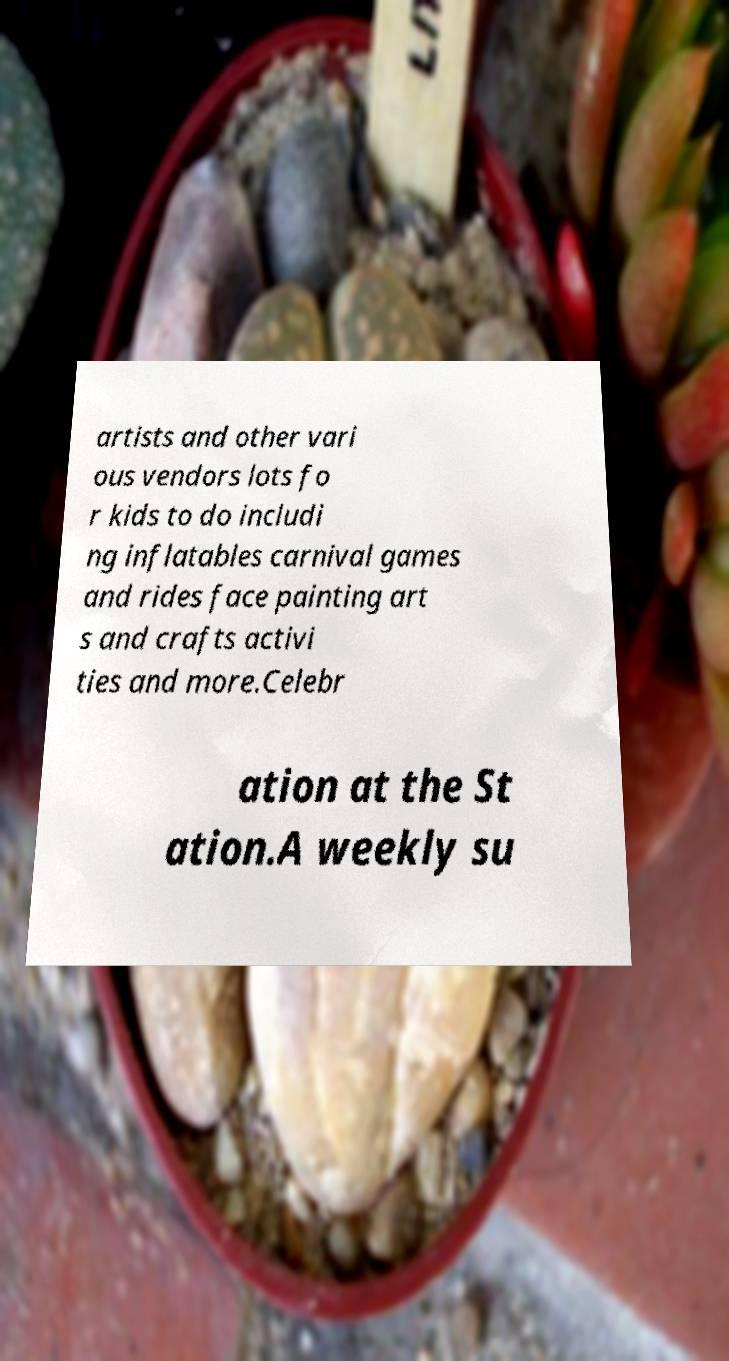Could you assist in decoding the text presented in this image and type it out clearly? artists and other vari ous vendors lots fo r kids to do includi ng inflatables carnival games and rides face painting art s and crafts activi ties and more.Celebr ation at the St ation.A weekly su 